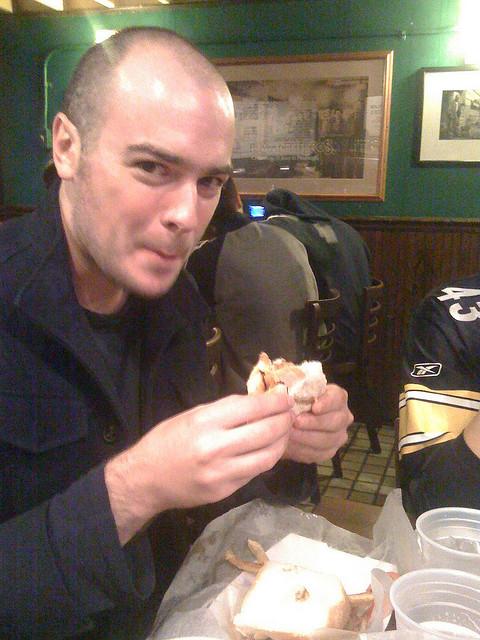What color is the top half of the wall?
Write a very short answer. Green. What kind of sandwich is he eating?
Short answer required. Chicken. Who is smiling?
Write a very short answer. Man. 